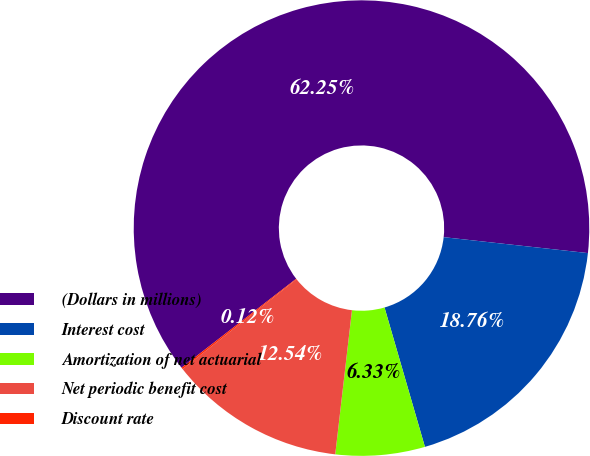Convert chart to OTSL. <chart><loc_0><loc_0><loc_500><loc_500><pie_chart><fcel>(Dollars in millions)<fcel>Interest cost<fcel>Amortization of net actuarial<fcel>Net periodic benefit cost<fcel>Discount rate<nl><fcel>62.25%<fcel>18.76%<fcel>6.33%<fcel>12.54%<fcel>0.12%<nl></chart> 